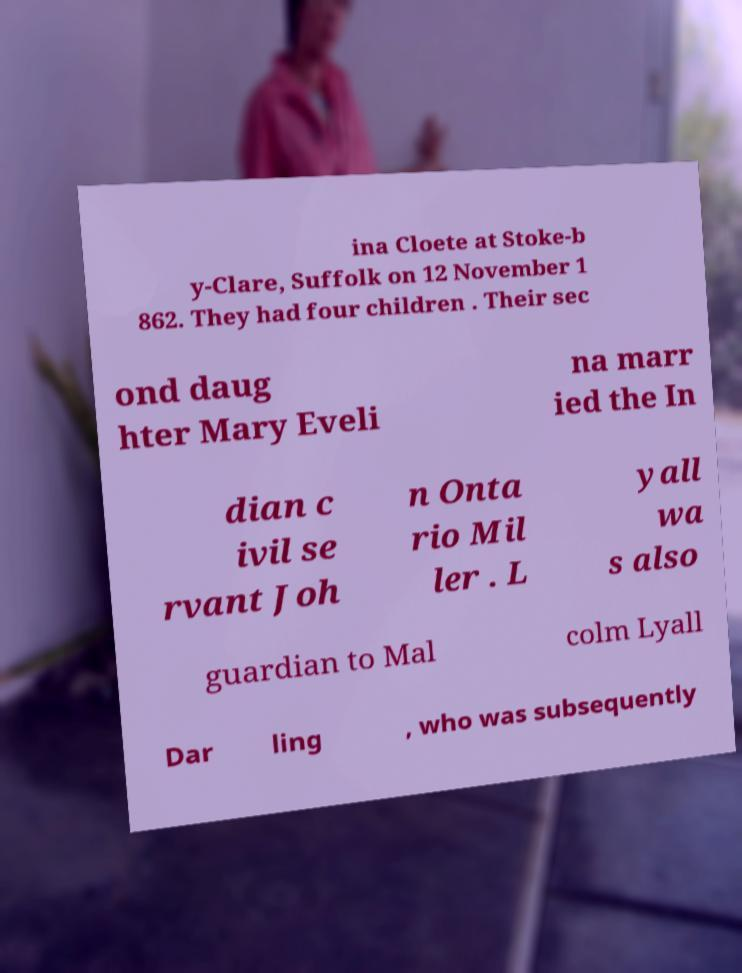Can you read and provide the text displayed in the image?This photo seems to have some interesting text. Can you extract and type it out for me? ina Cloete at Stoke-b y-Clare, Suffolk on 12 November 1 862. They had four children . Their sec ond daug hter Mary Eveli na marr ied the In dian c ivil se rvant Joh n Onta rio Mil ler . L yall wa s also guardian to Mal colm Lyall Dar ling , who was subsequently 